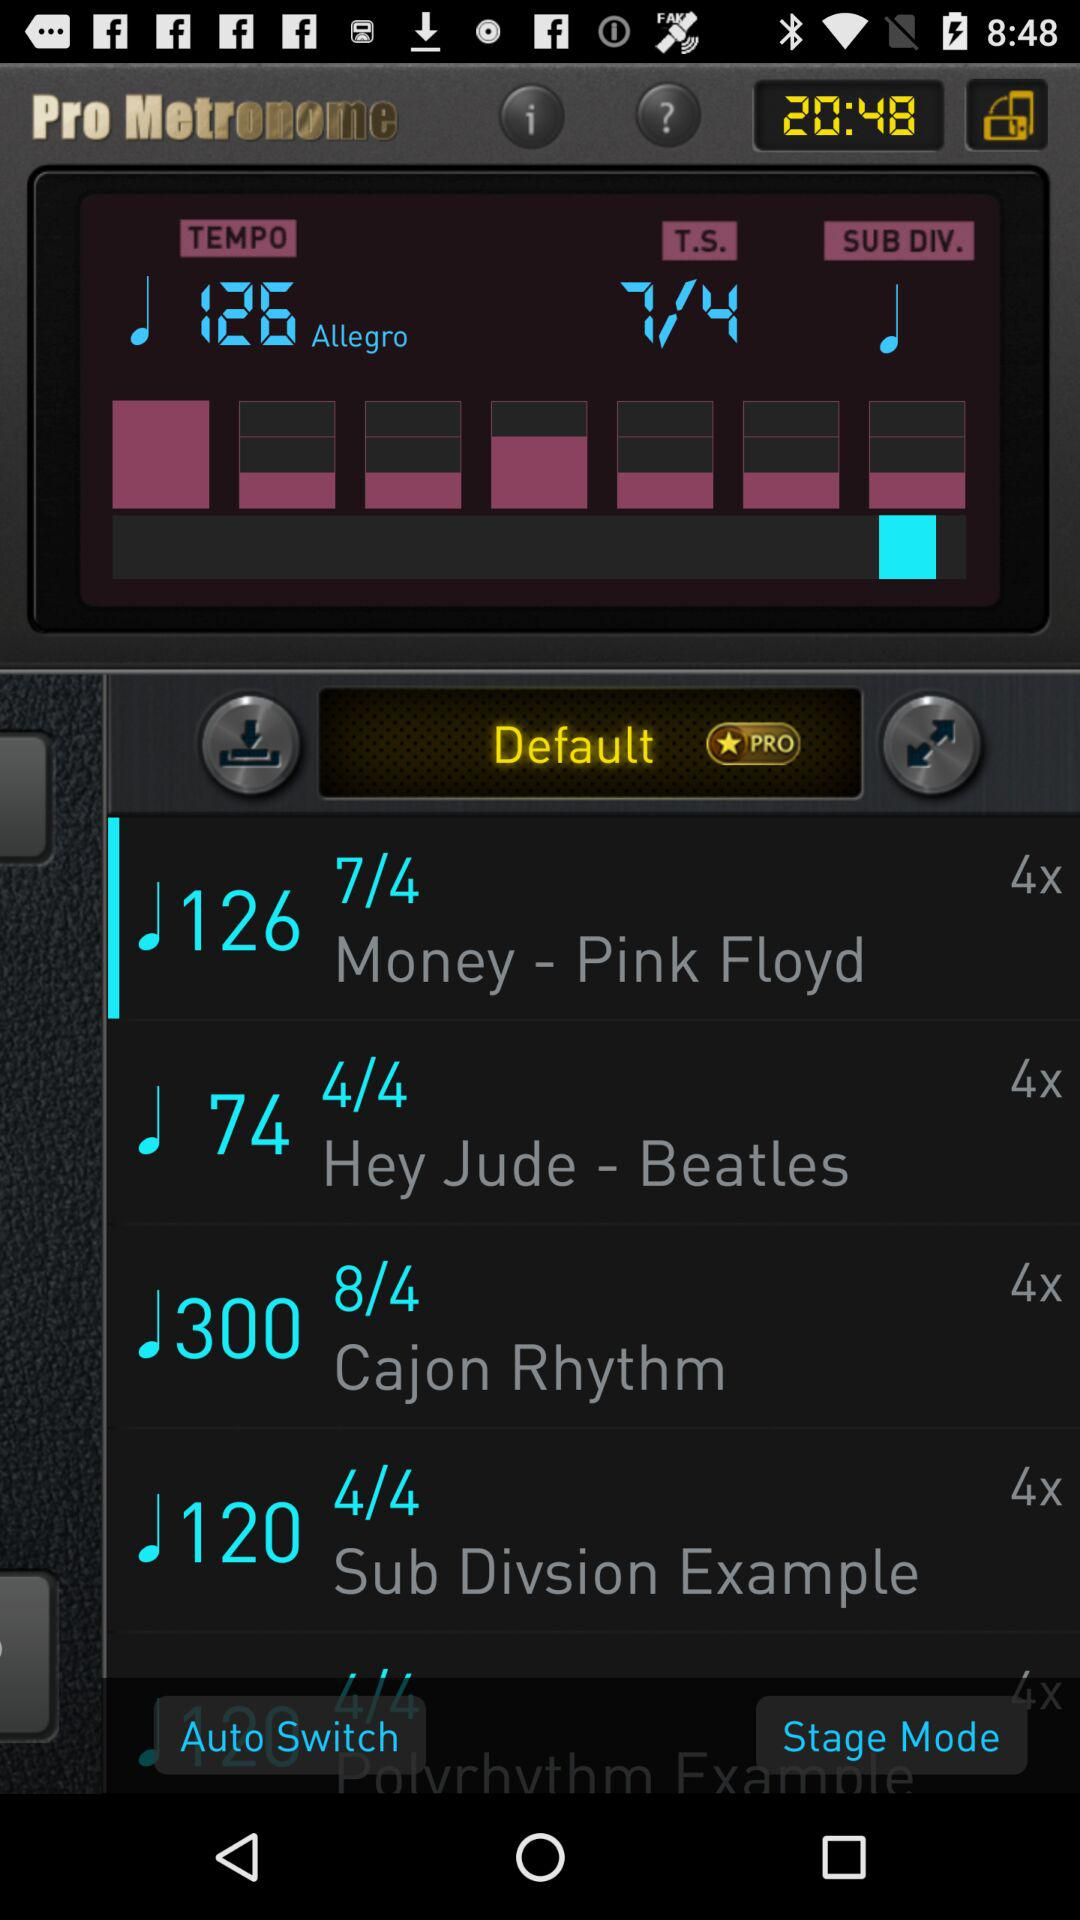What is the tempo? The tempo is 126. 